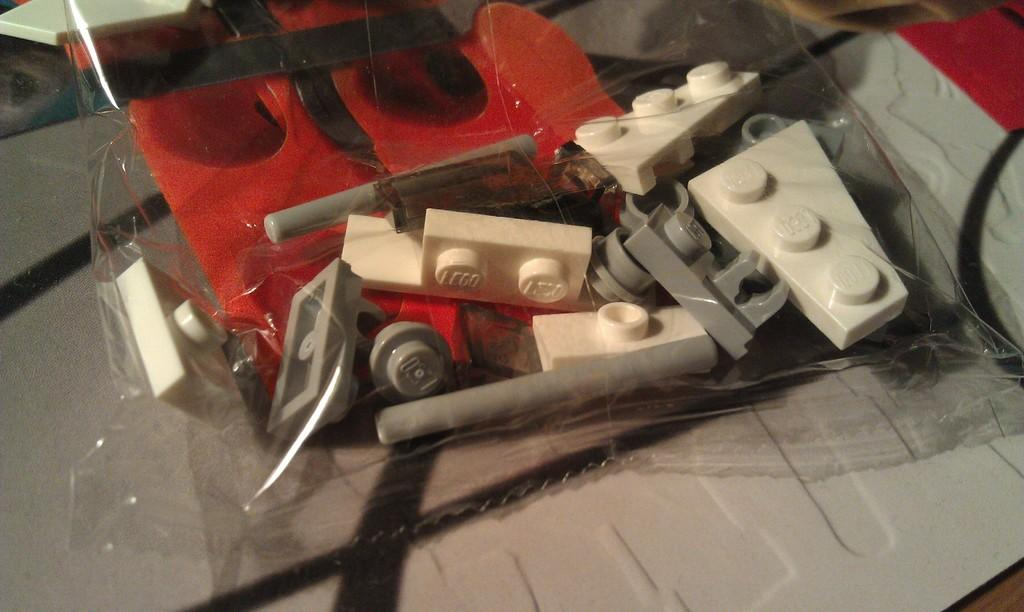What type of toys are in the image? There are building blocks in the image. How are the building blocks stored or protected? The building blocks are in a cover. What can be seen at the bottom of the image? There are objects at the bottom of the image. What type of material is present in the image? There is a wire in the image. How do the building blocks make a discovery in the image? The building blocks do not make a discovery in the image; they are inanimate objects. 